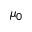<formula> <loc_0><loc_0><loc_500><loc_500>\mu _ { 0 }</formula> 